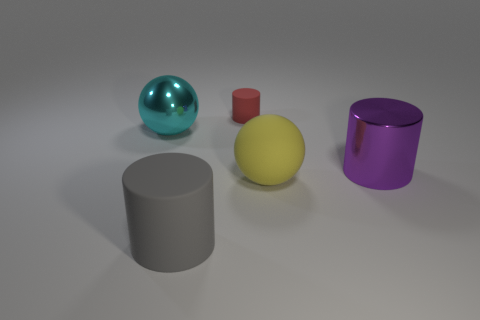Add 2 large green rubber cylinders. How many objects exist? 7 Subtract all cylinders. How many objects are left? 2 Subtract all brown metal cylinders. Subtract all big yellow things. How many objects are left? 4 Add 2 large gray rubber cylinders. How many large gray rubber cylinders are left? 3 Add 5 large purple cylinders. How many large purple cylinders exist? 6 Subtract 0 green spheres. How many objects are left? 5 